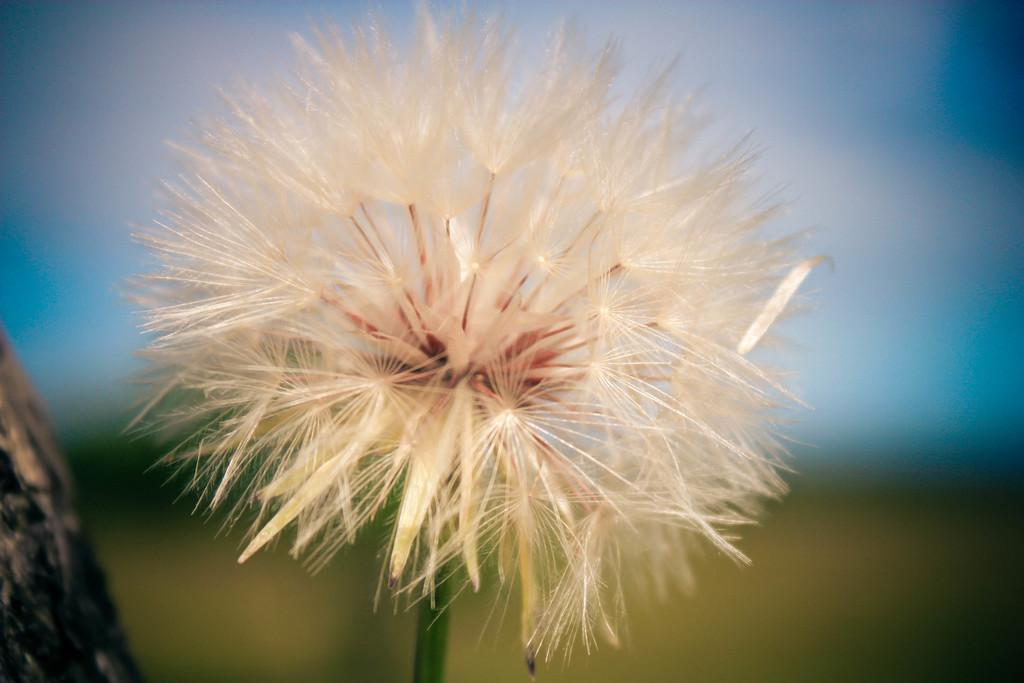What is the main subject of the image? The main subject of the image is a flower. Can you describe the color of the flower? The flower is cream-colored. What part of the flower is green in the image? There is a green stem associated with the flower. How would you describe the background of the image? The background of the image is blurred. What type of slave is depicted in the image? There is no depiction of a slave in the image; it features a cream-colored flower with a green stem and a blurred background. What role does the stem play in the ongoing war in the image? There is no war depicted in the image, and the stem is simply a part of the flower. 